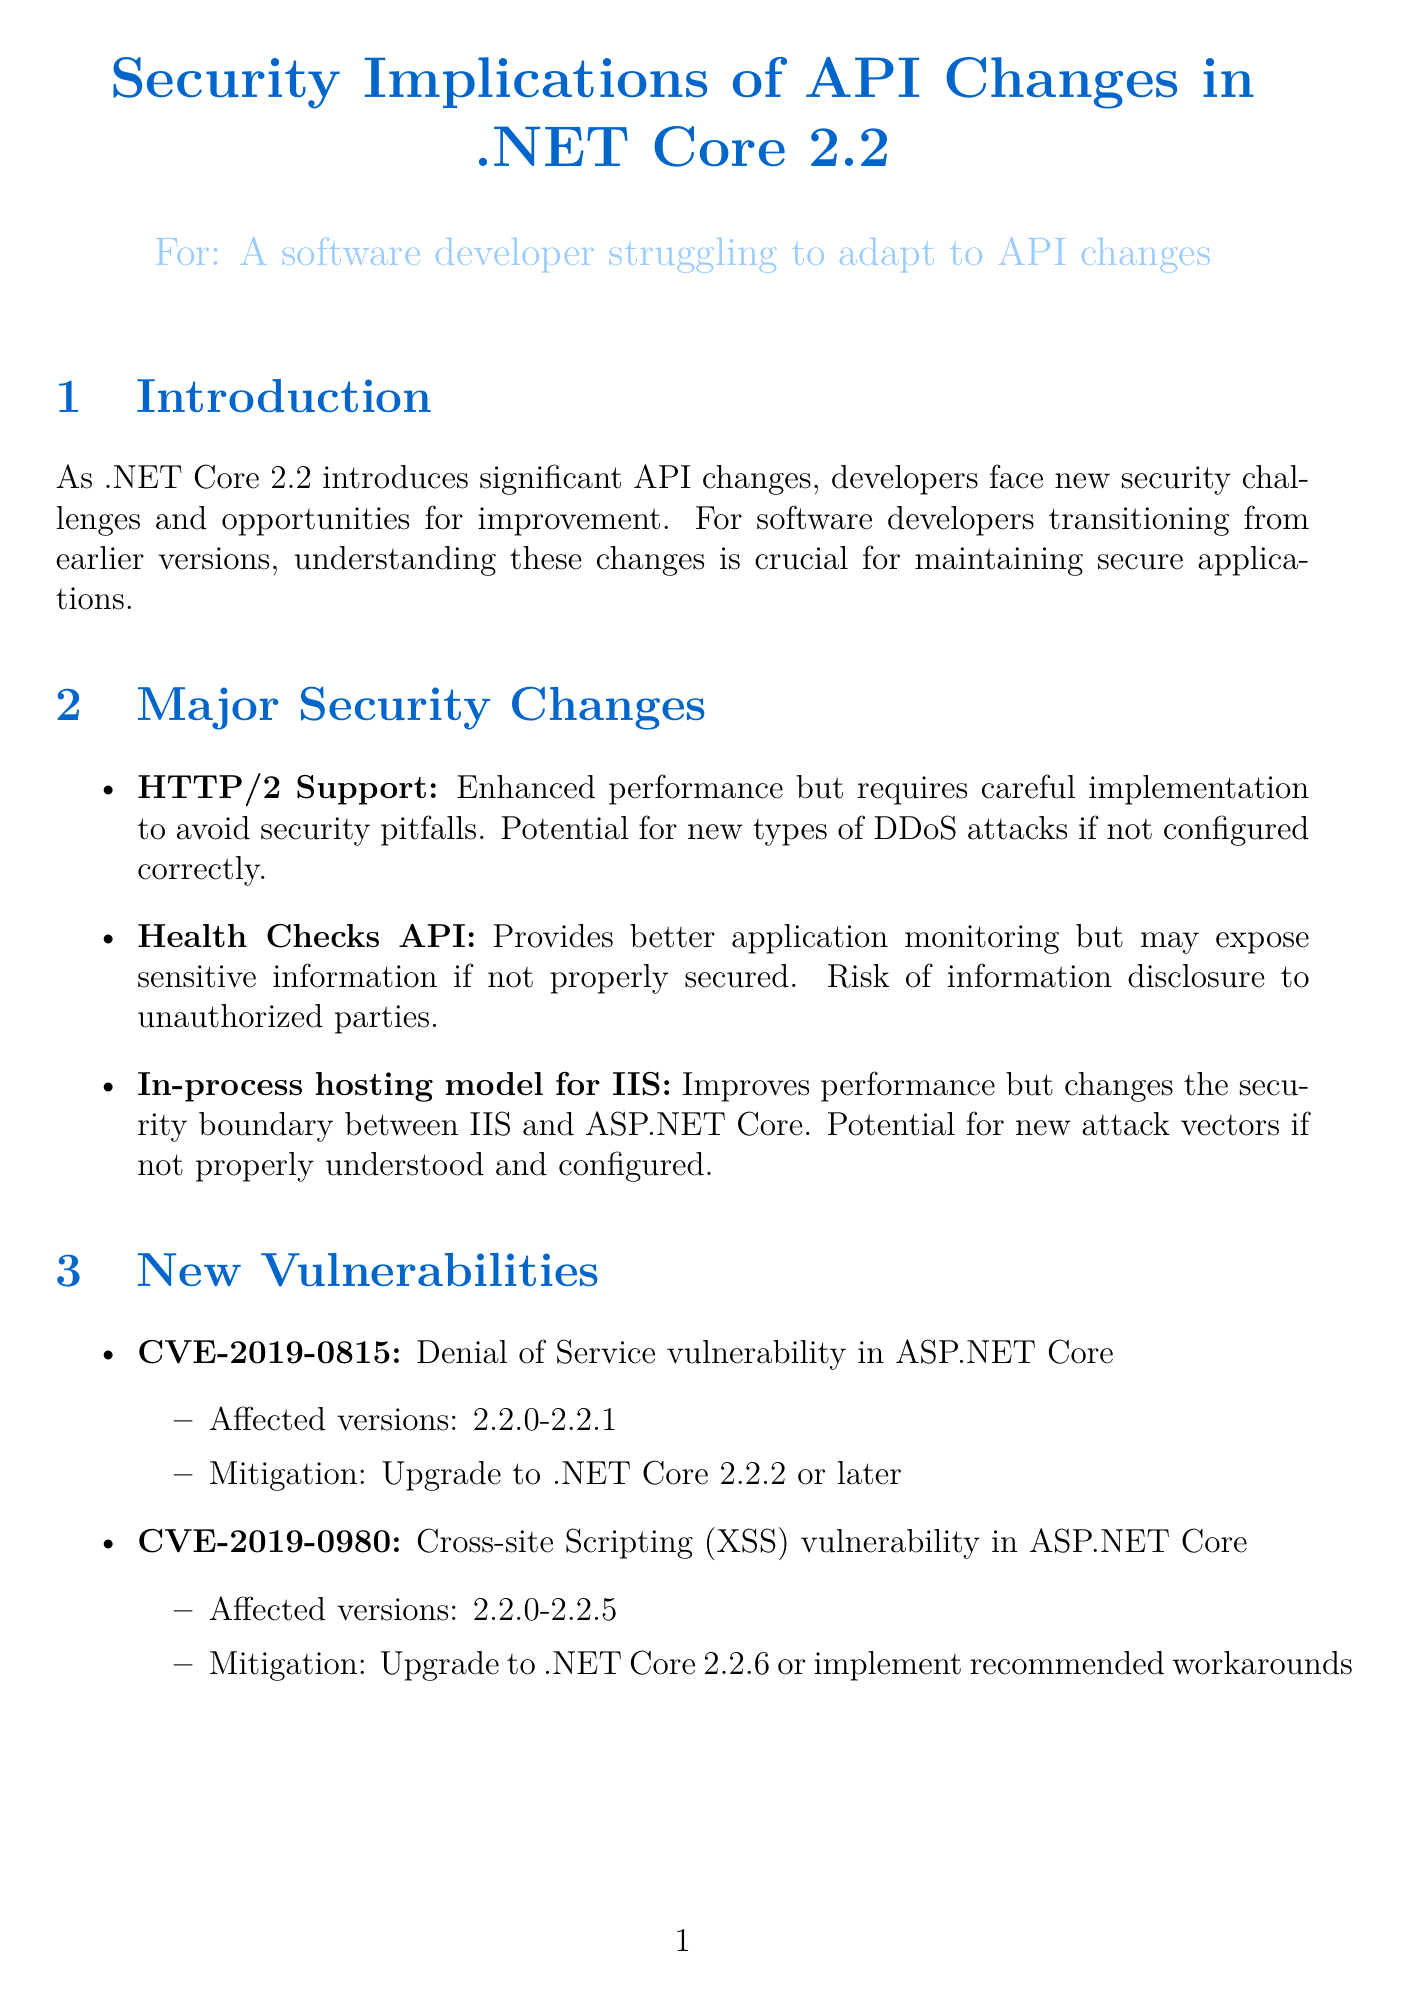What is the new support introduced in .NET Core 2.2? The document introduces HTTP/2 support as a significant change in .NET Core 2.2.
Answer: HTTP/2 support What mitigation is recommended for CVE-2019-0815? The document states that to mitigate this vulnerability, you should upgrade to .NET Core 2.2.2 or later.
Answer: Upgrade to .NET Core 2.2.2 or later What is a potential risk associated with the Health Checks API? The document specifies that it may expose sensitive information if not properly secured, leading to a risk of information disclosure.
Answer: Risk of information disclosure What are the two tools suggested for regular security audits? According to the document, the suggested tools for conducting thorough code reviews and penetration testing are SonarQube and OWASP ZAP.
Answer: SonarQube, OWASP ZAP How many best practices are listed in the document? The document outlines a total of five best practices.
Answer: Five What is a feature related to data protection improvements? The document highlights enhanced key management and encryption capabilities as part of data protection improvements.
Answer: Enhanced key management and encryption capabilities What type of vulnerability is CVE-2019-0980? The document identifies CVE-2019-0980 as a Cross-site Scripting (XSS) vulnerability.
Answer: Cross-site Scripting (XSS) What document is recommended for guidelines on addressing common web application security risks? The document references OWASP Top 10 for .NET developers for guidelines on common web application security risks.
Answer: OWASP Top 10 for .NET developers 